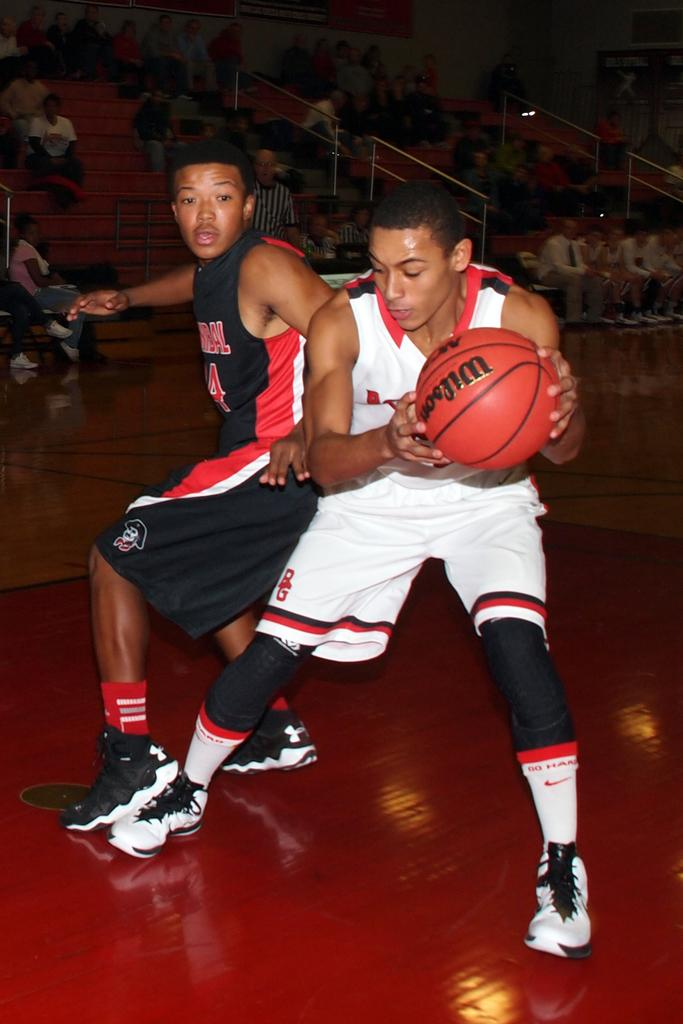<image>
Share a concise interpretation of the image provided. two basketball players playing with a Wilson basketball. 